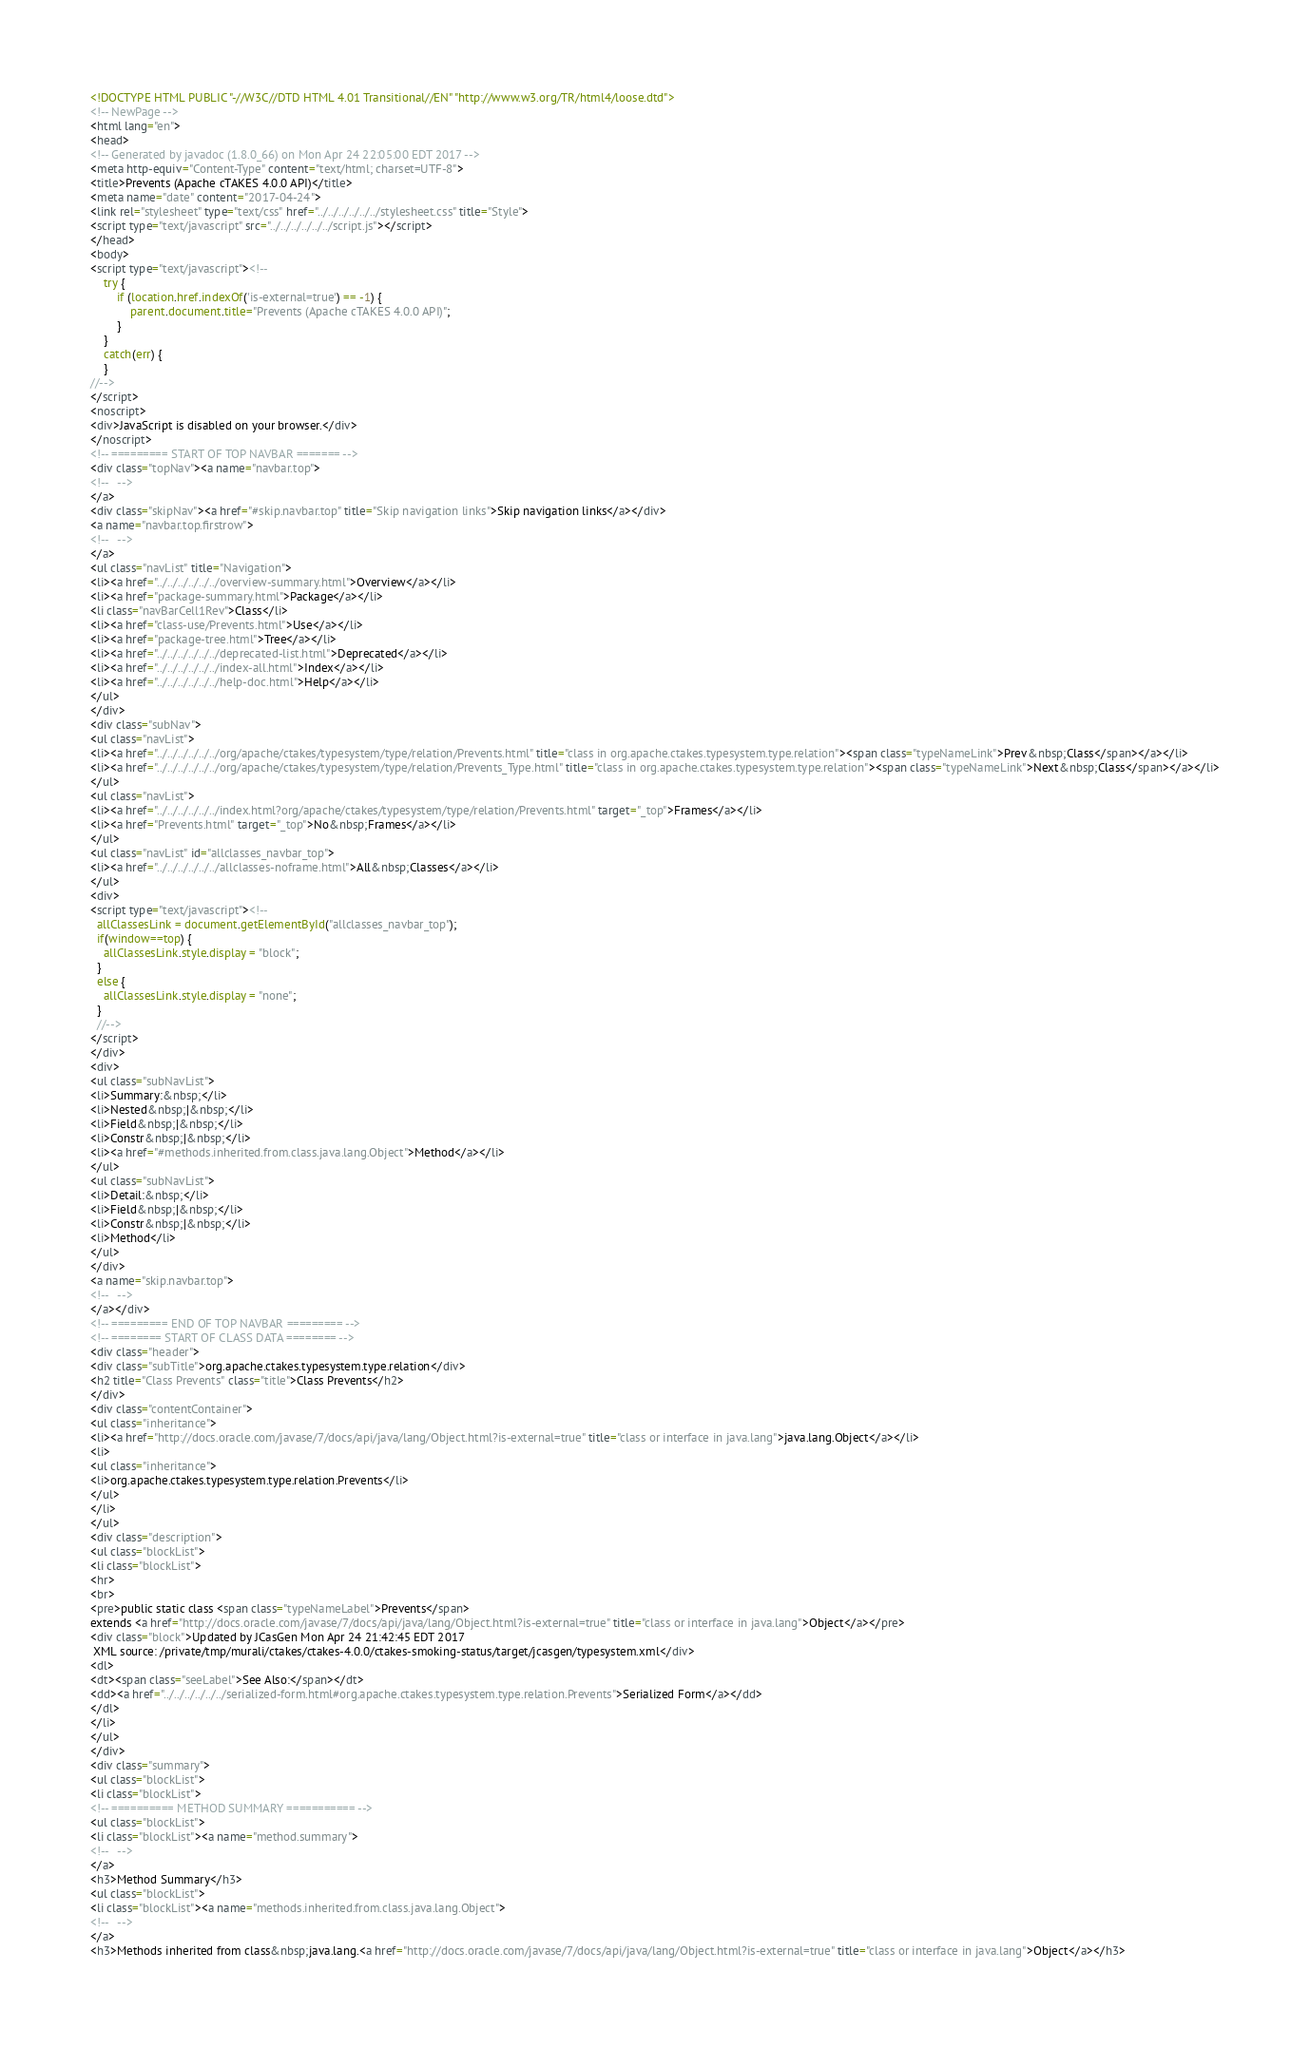Convert code to text. <code><loc_0><loc_0><loc_500><loc_500><_HTML_><!DOCTYPE HTML PUBLIC "-//W3C//DTD HTML 4.01 Transitional//EN" "http://www.w3.org/TR/html4/loose.dtd">
<!-- NewPage -->
<html lang="en">
<head>
<!-- Generated by javadoc (1.8.0_66) on Mon Apr 24 22:05:00 EDT 2017 -->
<meta http-equiv="Content-Type" content="text/html; charset=UTF-8">
<title>Prevents (Apache cTAKES 4.0.0 API)</title>
<meta name="date" content="2017-04-24">
<link rel="stylesheet" type="text/css" href="../../../../../../stylesheet.css" title="Style">
<script type="text/javascript" src="../../../../../../script.js"></script>
</head>
<body>
<script type="text/javascript"><!--
    try {
        if (location.href.indexOf('is-external=true') == -1) {
            parent.document.title="Prevents (Apache cTAKES 4.0.0 API)";
        }
    }
    catch(err) {
    }
//-->
</script>
<noscript>
<div>JavaScript is disabled on your browser.</div>
</noscript>
<!-- ========= START OF TOP NAVBAR ======= -->
<div class="topNav"><a name="navbar.top">
<!--   -->
</a>
<div class="skipNav"><a href="#skip.navbar.top" title="Skip navigation links">Skip navigation links</a></div>
<a name="navbar.top.firstrow">
<!--   -->
</a>
<ul class="navList" title="Navigation">
<li><a href="../../../../../../overview-summary.html">Overview</a></li>
<li><a href="package-summary.html">Package</a></li>
<li class="navBarCell1Rev">Class</li>
<li><a href="class-use/Prevents.html">Use</a></li>
<li><a href="package-tree.html">Tree</a></li>
<li><a href="../../../../../../deprecated-list.html">Deprecated</a></li>
<li><a href="../../../../../../index-all.html">Index</a></li>
<li><a href="../../../../../../help-doc.html">Help</a></li>
</ul>
</div>
<div class="subNav">
<ul class="navList">
<li><a href="../../../../../../org/apache/ctakes/typesystem/type/relation/Prevents.html" title="class in org.apache.ctakes.typesystem.type.relation"><span class="typeNameLink">Prev&nbsp;Class</span></a></li>
<li><a href="../../../../../../org/apache/ctakes/typesystem/type/relation/Prevents_Type.html" title="class in org.apache.ctakes.typesystem.type.relation"><span class="typeNameLink">Next&nbsp;Class</span></a></li>
</ul>
<ul class="navList">
<li><a href="../../../../../../index.html?org/apache/ctakes/typesystem/type/relation/Prevents.html" target="_top">Frames</a></li>
<li><a href="Prevents.html" target="_top">No&nbsp;Frames</a></li>
</ul>
<ul class="navList" id="allclasses_navbar_top">
<li><a href="../../../../../../allclasses-noframe.html">All&nbsp;Classes</a></li>
</ul>
<div>
<script type="text/javascript"><!--
  allClassesLink = document.getElementById("allclasses_navbar_top");
  if(window==top) {
    allClassesLink.style.display = "block";
  }
  else {
    allClassesLink.style.display = "none";
  }
  //-->
</script>
</div>
<div>
<ul class="subNavList">
<li>Summary:&nbsp;</li>
<li>Nested&nbsp;|&nbsp;</li>
<li>Field&nbsp;|&nbsp;</li>
<li>Constr&nbsp;|&nbsp;</li>
<li><a href="#methods.inherited.from.class.java.lang.Object">Method</a></li>
</ul>
<ul class="subNavList">
<li>Detail:&nbsp;</li>
<li>Field&nbsp;|&nbsp;</li>
<li>Constr&nbsp;|&nbsp;</li>
<li>Method</li>
</ul>
</div>
<a name="skip.navbar.top">
<!--   -->
</a></div>
<!-- ========= END OF TOP NAVBAR ========= -->
<!-- ======== START OF CLASS DATA ======== -->
<div class="header">
<div class="subTitle">org.apache.ctakes.typesystem.type.relation</div>
<h2 title="Class Prevents" class="title">Class Prevents</h2>
</div>
<div class="contentContainer">
<ul class="inheritance">
<li><a href="http://docs.oracle.com/javase/7/docs/api/java/lang/Object.html?is-external=true" title="class or interface in java.lang">java.lang.Object</a></li>
<li>
<ul class="inheritance">
<li>org.apache.ctakes.typesystem.type.relation.Prevents</li>
</ul>
</li>
</ul>
<div class="description">
<ul class="blockList">
<li class="blockList">
<hr>
<br>
<pre>public static class <span class="typeNameLabel">Prevents</span>
extends <a href="http://docs.oracle.com/javase/7/docs/api/java/lang/Object.html?is-external=true" title="class or interface in java.lang">Object</a></pre>
<div class="block">Updated by JCasGen Mon Apr 24 21:42:45 EDT 2017
 XML source: /private/tmp/murali/ctakes/ctakes-4.0.0/ctakes-smoking-status/target/jcasgen/typesystem.xml</div>
<dl>
<dt><span class="seeLabel">See Also:</span></dt>
<dd><a href="../../../../../../serialized-form.html#org.apache.ctakes.typesystem.type.relation.Prevents">Serialized Form</a></dd>
</dl>
</li>
</ul>
</div>
<div class="summary">
<ul class="blockList">
<li class="blockList">
<!-- ========== METHOD SUMMARY =========== -->
<ul class="blockList">
<li class="blockList"><a name="method.summary">
<!--   -->
</a>
<h3>Method Summary</h3>
<ul class="blockList">
<li class="blockList"><a name="methods.inherited.from.class.java.lang.Object">
<!--   -->
</a>
<h3>Methods inherited from class&nbsp;java.lang.<a href="http://docs.oracle.com/javase/7/docs/api/java/lang/Object.html?is-external=true" title="class or interface in java.lang">Object</a></h3></code> 